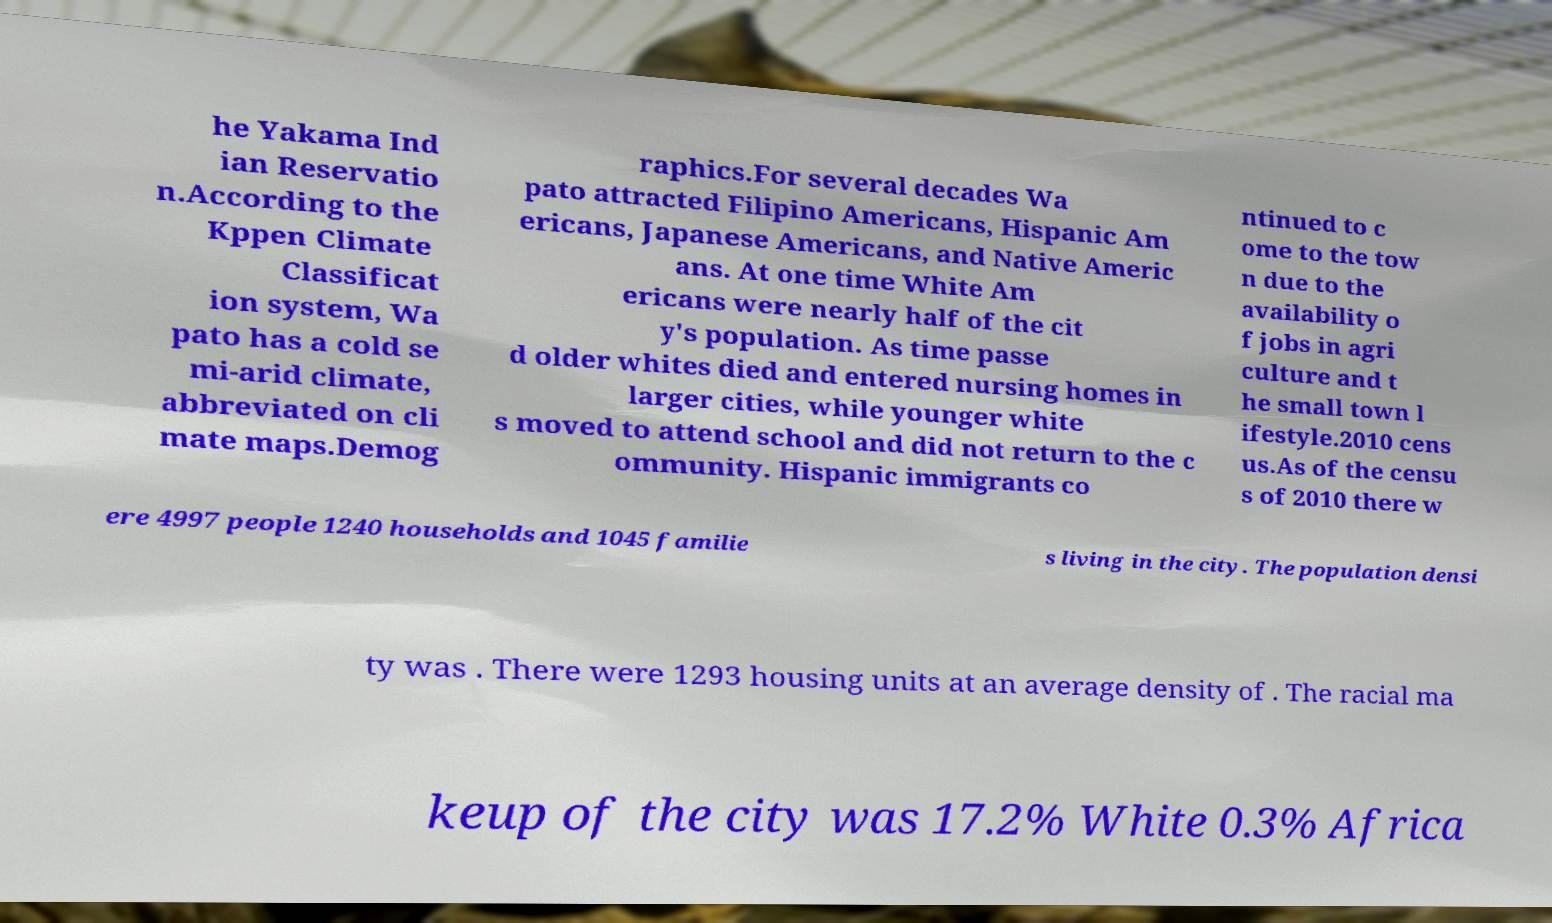I need the written content from this picture converted into text. Can you do that? he Yakama Ind ian Reservatio n.According to the Kppen Climate Classificat ion system, Wa pato has a cold se mi-arid climate, abbreviated on cli mate maps.Demog raphics.For several decades Wa pato attracted Filipino Americans, Hispanic Am ericans, Japanese Americans, and Native Americ ans. At one time White Am ericans were nearly half of the cit y's population. As time passe d older whites died and entered nursing homes in larger cities, while younger white s moved to attend school and did not return to the c ommunity. Hispanic immigrants co ntinued to c ome to the tow n due to the availability o f jobs in agri culture and t he small town l ifestyle.2010 cens us.As of the censu s of 2010 there w ere 4997 people 1240 households and 1045 familie s living in the city. The population densi ty was . There were 1293 housing units at an average density of . The racial ma keup of the city was 17.2% White 0.3% Africa 